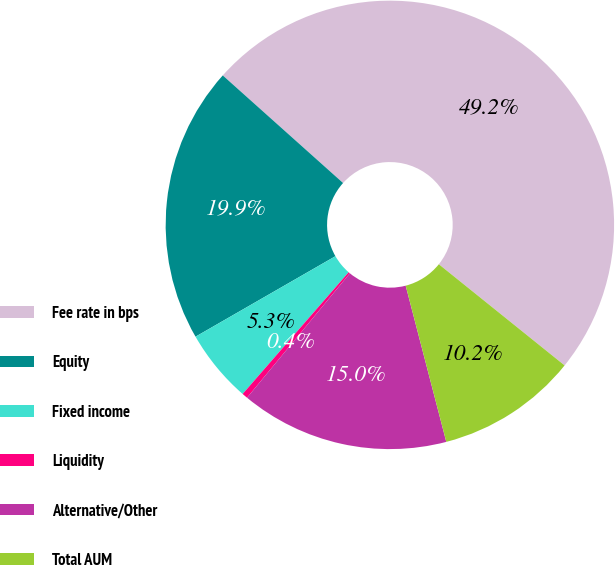Convert chart. <chart><loc_0><loc_0><loc_500><loc_500><pie_chart><fcel>Fee rate in bps<fcel>Equity<fcel>Fixed income<fcel>Liquidity<fcel>Alternative/Other<fcel>Total AUM<nl><fcel>49.17%<fcel>19.92%<fcel>5.29%<fcel>0.41%<fcel>15.04%<fcel>10.17%<nl></chart> 